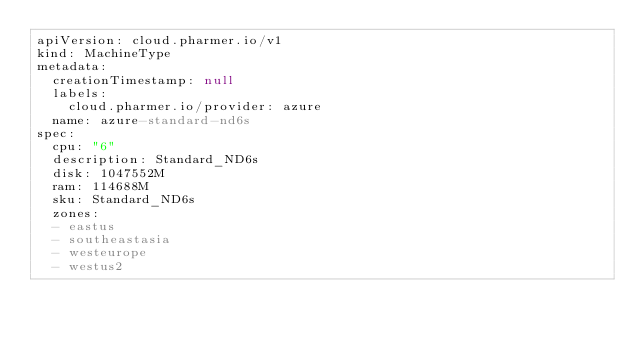<code> <loc_0><loc_0><loc_500><loc_500><_YAML_>apiVersion: cloud.pharmer.io/v1
kind: MachineType
metadata:
  creationTimestamp: null
  labels:
    cloud.pharmer.io/provider: azure
  name: azure-standard-nd6s
spec:
  cpu: "6"
  description: Standard_ND6s
  disk: 1047552M
  ram: 114688M
  sku: Standard_ND6s
  zones:
  - eastus
  - southeastasia
  - westeurope
  - westus2
</code> 